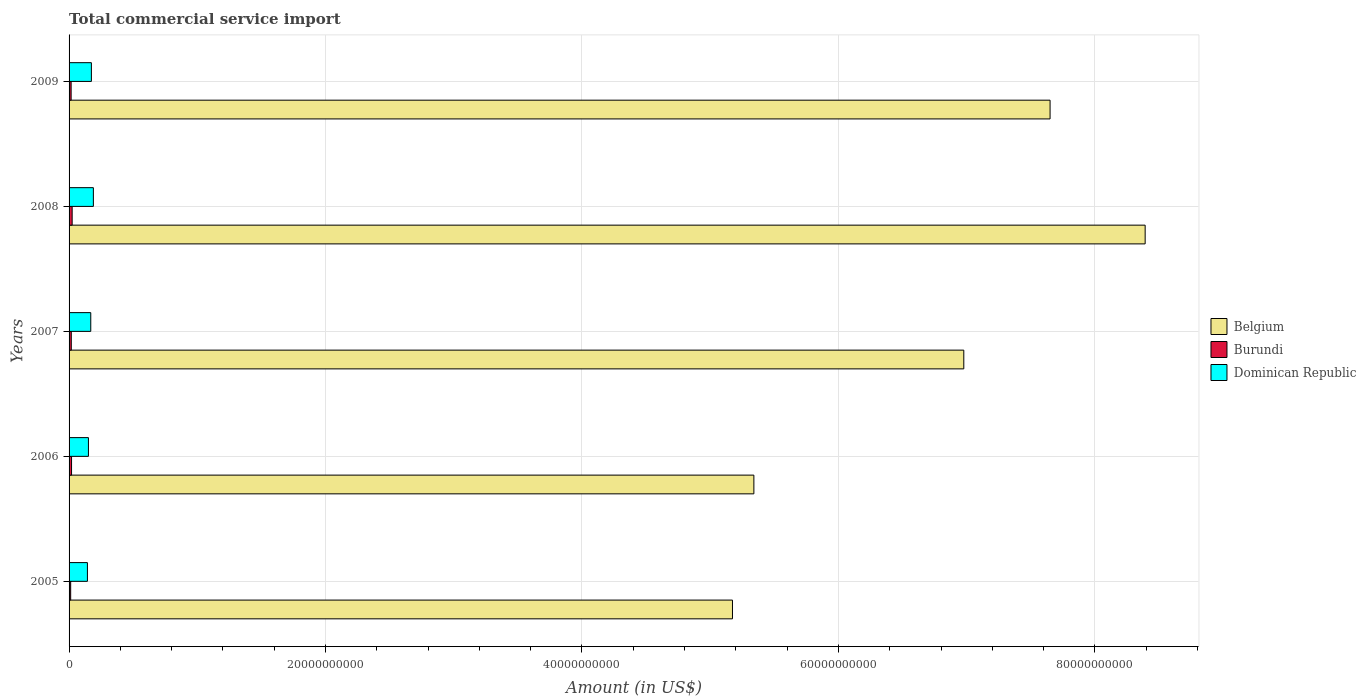How many different coloured bars are there?
Keep it short and to the point. 3. How many groups of bars are there?
Provide a succinct answer. 5. How many bars are there on the 5th tick from the top?
Your answer should be compact. 3. What is the label of the 3rd group of bars from the top?
Your answer should be very brief. 2007. In how many cases, is the number of bars for a given year not equal to the number of legend labels?
Make the answer very short. 0. What is the total commercial service import in Dominican Republic in 2006?
Ensure brevity in your answer.  1.51e+09. Across all years, what is the maximum total commercial service import in Dominican Republic?
Your answer should be very brief. 1.89e+09. Across all years, what is the minimum total commercial service import in Dominican Republic?
Offer a very short reply. 1.43e+09. In which year was the total commercial service import in Dominican Republic maximum?
Offer a terse response. 2008. In which year was the total commercial service import in Dominican Republic minimum?
Keep it short and to the point. 2005. What is the total total commercial service import in Burundi in the graph?
Offer a terse response. 8.92e+08. What is the difference between the total commercial service import in Belgium in 2006 and that in 2008?
Provide a short and direct response. -3.05e+1. What is the difference between the total commercial service import in Dominican Republic in 2005 and the total commercial service import in Burundi in 2009?
Offer a terse response. 1.27e+09. What is the average total commercial service import in Belgium per year?
Provide a succinct answer. 6.71e+1. In the year 2009, what is the difference between the total commercial service import in Dominican Republic and total commercial service import in Burundi?
Make the answer very short. 1.58e+09. In how many years, is the total commercial service import in Dominican Republic greater than 24000000000 US$?
Provide a succinct answer. 0. What is the ratio of the total commercial service import in Belgium in 2008 to that in 2009?
Keep it short and to the point. 1.1. What is the difference between the highest and the second highest total commercial service import in Dominican Republic?
Keep it short and to the point. 1.54e+08. What is the difference between the highest and the lowest total commercial service import in Belgium?
Ensure brevity in your answer.  3.22e+1. What does the 1st bar from the top in 2005 represents?
Keep it short and to the point. Dominican Republic. What does the 2nd bar from the bottom in 2009 represents?
Your answer should be compact. Burundi. How many bars are there?
Provide a succinct answer. 15. How many years are there in the graph?
Provide a short and direct response. 5. Does the graph contain grids?
Offer a very short reply. Yes. Where does the legend appear in the graph?
Provide a short and direct response. Center right. How are the legend labels stacked?
Offer a very short reply. Vertical. What is the title of the graph?
Provide a short and direct response. Total commercial service import. What is the Amount (in US$) of Belgium in 2005?
Your answer should be compact. 5.17e+1. What is the Amount (in US$) of Burundi in 2005?
Your response must be concise. 1.25e+08. What is the Amount (in US$) of Dominican Republic in 2005?
Your answer should be very brief. 1.43e+09. What is the Amount (in US$) of Belgium in 2006?
Offer a very short reply. 5.34e+1. What is the Amount (in US$) in Burundi in 2006?
Provide a short and direct response. 1.93e+08. What is the Amount (in US$) in Dominican Republic in 2006?
Give a very brief answer. 1.51e+09. What is the Amount (in US$) of Belgium in 2007?
Your answer should be very brief. 6.98e+1. What is the Amount (in US$) of Burundi in 2007?
Your response must be concise. 1.73e+08. What is the Amount (in US$) in Dominican Republic in 2007?
Make the answer very short. 1.69e+09. What is the Amount (in US$) of Belgium in 2008?
Keep it short and to the point. 8.39e+1. What is the Amount (in US$) of Burundi in 2008?
Provide a succinct answer. 2.41e+08. What is the Amount (in US$) in Dominican Republic in 2008?
Provide a short and direct response. 1.89e+09. What is the Amount (in US$) in Belgium in 2009?
Your answer should be compact. 7.65e+1. What is the Amount (in US$) in Burundi in 2009?
Make the answer very short. 1.60e+08. What is the Amount (in US$) of Dominican Republic in 2009?
Ensure brevity in your answer.  1.74e+09. Across all years, what is the maximum Amount (in US$) in Belgium?
Offer a terse response. 8.39e+1. Across all years, what is the maximum Amount (in US$) in Burundi?
Ensure brevity in your answer.  2.41e+08. Across all years, what is the maximum Amount (in US$) of Dominican Republic?
Ensure brevity in your answer.  1.89e+09. Across all years, what is the minimum Amount (in US$) of Belgium?
Provide a succinct answer. 5.17e+1. Across all years, what is the minimum Amount (in US$) of Burundi?
Provide a short and direct response. 1.25e+08. Across all years, what is the minimum Amount (in US$) in Dominican Republic?
Your answer should be compact. 1.43e+09. What is the total Amount (in US$) of Belgium in the graph?
Provide a short and direct response. 3.35e+11. What is the total Amount (in US$) in Burundi in the graph?
Offer a terse response. 8.92e+08. What is the total Amount (in US$) in Dominican Republic in the graph?
Offer a very short reply. 8.27e+09. What is the difference between the Amount (in US$) in Belgium in 2005 and that in 2006?
Your answer should be compact. -1.67e+09. What is the difference between the Amount (in US$) in Burundi in 2005 and that in 2006?
Keep it short and to the point. -6.88e+07. What is the difference between the Amount (in US$) of Dominican Republic in 2005 and that in 2006?
Offer a terse response. -7.95e+07. What is the difference between the Amount (in US$) in Belgium in 2005 and that in 2007?
Your answer should be compact. -1.80e+1. What is the difference between the Amount (in US$) of Burundi in 2005 and that in 2007?
Your response must be concise. -4.82e+07. What is the difference between the Amount (in US$) of Dominican Republic in 2005 and that in 2007?
Your answer should be very brief. -2.61e+08. What is the difference between the Amount (in US$) in Belgium in 2005 and that in 2008?
Ensure brevity in your answer.  -3.22e+1. What is the difference between the Amount (in US$) of Burundi in 2005 and that in 2008?
Ensure brevity in your answer.  -1.16e+08. What is the difference between the Amount (in US$) of Dominican Republic in 2005 and that in 2008?
Give a very brief answer. -4.64e+08. What is the difference between the Amount (in US$) of Belgium in 2005 and that in 2009?
Provide a short and direct response. -2.48e+1. What is the difference between the Amount (in US$) in Burundi in 2005 and that in 2009?
Offer a terse response. -3.54e+07. What is the difference between the Amount (in US$) in Dominican Republic in 2005 and that in 2009?
Your answer should be compact. -3.10e+08. What is the difference between the Amount (in US$) in Belgium in 2006 and that in 2007?
Give a very brief answer. -1.64e+1. What is the difference between the Amount (in US$) in Burundi in 2006 and that in 2007?
Offer a terse response. 2.06e+07. What is the difference between the Amount (in US$) in Dominican Republic in 2006 and that in 2007?
Your answer should be compact. -1.81e+08. What is the difference between the Amount (in US$) of Belgium in 2006 and that in 2008?
Offer a terse response. -3.05e+1. What is the difference between the Amount (in US$) of Burundi in 2006 and that in 2008?
Keep it short and to the point. -4.70e+07. What is the difference between the Amount (in US$) of Dominican Republic in 2006 and that in 2008?
Your response must be concise. -3.84e+08. What is the difference between the Amount (in US$) in Belgium in 2006 and that in 2009?
Provide a succinct answer. -2.31e+1. What is the difference between the Amount (in US$) in Burundi in 2006 and that in 2009?
Give a very brief answer. 3.34e+07. What is the difference between the Amount (in US$) of Dominican Republic in 2006 and that in 2009?
Your response must be concise. -2.31e+08. What is the difference between the Amount (in US$) in Belgium in 2007 and that in 2008?
Offer a very short reply. -1.41e+1. What is the difference between the Amount (in US$) of Burundi in 2007 and that in 2008?
Provide a succinct answer. -6.77e+07. What is the difference between the Amount (in US$) of Dominican Republic in 2007 and that in 2008?
Offer a terse response. -2.03e+08. What is the difference between the Amount (in US$) of Belgium in 2007 and that in 2009?
Ensure brevity in your answer.  -6.73e+09. What is the difference between the Amount (in US$) in Burundi in 2007 and that in 2009?
Your response must be concise. 1.27e+07. What is the difference between the Amount (in US$) of Dominican Republic in 2007 and that in 2009?
Your answer should be compact. -4.96e+07. What is the difference between the Amount (in US$) of Belgium in 2008 and that in 2009?
Offer a terse response. 7.42e+09. What is the difference between the Amount (in US$) of Burundi in 2008 and that in 2009?
Offer a very short reply. 8.04e+07. What is the difference between the Amount (in US$) of Dominican Republic in 2008 and that in 2009?
Give a very brief answer. 1.54e+08. What is the difference between the Amount (in US$) of Belgium in 2005 and the Amount (in US$) of Burundi in 2006?
Provide a short and direct response. 5.15e+1. What is the difference between the Amount (in US$) of Belgium in 2005 and the Amount (in US$) of Dominican Republic in 2006?
Your answer should be very brief. 5.02e+1. What is the difference between the Amount (in US$) in Burundi in 2005 and the Amount (in US$) in Dominican Republic in 2006?
Offer a terse response. -1.39e+09. What is the difference between the Amount (in US$) of Belgium in 2005 and the Amount (in US$) of Burundi in 2007?
Your answer should be compact. 5.16e+1. What is the difference between the Amount (in US$) of Belgium in 2005 and the Amount (in US$) of Dominican Republic in 2007?
Give a very brief answer. 5.00e+1. What is the difference between the Amount (in US$) in Burundi in 2005 and the Amount (in US$) in Dominican Republic in 2007?
Your answer should be very brief. -1.57e+09. What is the difference between the Amount (in US$) in Belgium in 2005 and the Amount (in US$) in Burundi in 2008?
Offer a terse response. 5.15e+1. What is the difference between the Amount (in US$) in Belgium in 2005 and the Amount (in US$) in Dominican Republic in 2008?
Make the answer very short. 4.98e+1. What is the difference between the Amount (in US$) in Burundi in 2005 and the Amount (in US$) in Dominican Republic in 2008?
Offer a terse response. -1.77e+09. What is the difference between the Amount (in US$) of Belgium in 2005 and the Amount (in US$) of Burundi in 2009?
Your answer should be very brief. 5.16e+1. What is the difference between the Amount (in US$) of Belgium in 2005 and the Amount (in US$) of Dominican Republic in 2009?
Offer a very short reply. 5.00e+1. What is the difference between the Amount (in US$) of Burundi in 2005 and the Amount (in US$) of Dominican Republic in 2009?
Offer a very short reply. -1.62e+09. What is the difference between the Amount (in US$) in Belgium in 2006 and the Amount (in US$) in Burundi in 2007?
Ensure brevity in your answer.  5.32e+1. What is the difference between the Amount (in US$) of Belgium in 2006 and the Amount (in US$) of Dominican Republic in 2007?
Provide a succinct answer. 5.17e+1. What is the difference between the Amount (in US$) of Burundi in 2006 and the Amount (in US$) of Dominican Republic in 2007?
Offer a very short reply. -1.50e+09. What is the difference between the Amount (in US$) of Belgium in 2006 and the Amount (in US$) of Burundi in 2008?
Your answer should be very brief. 5.32e+1. What is the difference between the Amount (in US$) in Belgium in 2006 and the Amount (in US$) in Dominican Republic in 2008?
Provide a succinct answer. 5.15e+1. What is the difference between the Amount (in US$) of Burundi in 2006 and the Amount (in US$) of Dominican Republic in 2008?
Provide a short and direct response. -1.70e+09. What is the difference between the Amount (in US$) of Belgium in 2006 and the Amount (in US$) of Burundi in 2009?
Your response must be concise. 5.32e+1. What is the difference between the Amount (in US$) of Belgium in 2006 and the Amount (in US$) of Dominican Republic in 2009?
Your answer should be compact. 5.17e+1. What is the difference between the Amount (in US$) in Burundi in 2006 and the Amount (in US$) in Dominican Republic in 2009?
Offer a terse response. -1.55e+09. What is the difference between the Amount (in US$) in Belgium in 2007 and the Amount (in US$) in Burundi in 2008?
Offer a terse response. 6.95e+1. What is the difference between the Amount (in US$) in Belgium in 2007 and the Amount (in US$) in Dominican Republic in 2008?
Make the answer very short. 6.79e+1. What is the difference between the Amount (in US$) of Burundi in 2007 and the Amount (in US$) of Dominican Republic in 2008?
Give a very brief answer. -1.72e+09. What is the difference between the Amount (in US$) of Belgium in 2007 and the Amount (in US$) of Burundi in 2009?
Keep it short and to the point. 6.96e+1. What is the difference between the Amount (in US$) of Belgium in 2007 and the Amount (in US$) of Dominican Republic in 2009?
Your response must be concise. 6.80e+1. What is the difference between the Amount (in US$) in Burundi in 2007 and the Amount (in US$) in Dominican Republic in 2009?
Your answer should be compact. -1.57e+09. What is the difference between the Amount (in US$) in Belgium in 2008 and the Amount (in US$) in Burundi in 2009?
Give a very brief answer. 8.38e+1. What is the difference between the Amount (in US$) of Belgium in 2008 and the Amount (in US$) of Dominican Republic in 2009?
Provide a succinct answer. 8.22e+1. What is the difference between the Amount (in US$) of Burundi in 2008 and the Amount (in US$) of Dominican Republic in 2009?
Offer a very short reply. -1.50e+09. What is the average Amount (in US$) of Belgium per year?
Offer a very short reply. 6.71e+1. What is the average Amount (in US$) of Burundi per year?
Keep it short and to the point. 1.78e+08. What is the average Amount (in US$) of Dominican Republic per year?
Make the answer very short. 1.65e+09. In the year 2005, what is the difference between the Amount (in US$) of Belgium and Amount (in US$) of Burundi?
Your response must be concise. 5.16e+1. In the year 2005, what is the difference between the Amount (in US$) in Belgium and Amount (in US$) in Dominican Republic?
Provide a succinct answer. 5.03e+1. In the year 2005, what is the difference between the Amount (in US$) of Burundi and Amount (in US$) of Dominican Republic?
Offer a very short reply. -1.31e+09. In the year 2006, what is the difference between the Amount (in US$) of Belgium and Amount (in US$) of Burundi?
Provide a short and direct response. 5.32e+1. In the year 2006, what is the difference between the Amount (in US$) in Belgium and Amount (in US$) in Dominican Republic?
Your response must be concise. 5.19e+1. In the year 2006, what is the difference between the Amount (in US$) in Burundi and Amount (in US$) in Dominican Republic?
Provide a succinct answer. -1.32e+09. In the year 2007, what is the difference between the Amount (in US$) of Belgium and Amount (in US$) of Burundi?
Give a very brief answer. 6.96e+1. In the year 2007, what is the difference between the Amount (in US$) of Belgium and Amount (in US$) of Dominican Republic?
Give a very brief answer. 6.81e+1. In the year 2007, what is the difference between the Amount (in US$) of Burundi and Amount (in US$) of Dominican Republic?
Provide a short and direct response. -1.52e+09. In the year 2008, what is the difference between the Amount (in US$) of Belgium and Amount (in US$) of Burundi?
Keep it short and to the point. 8.37e+1. In the year 2008, what is the difference between the Amount (in US$) of Belgium and Amount (in US$) of Dominican Republic?
Give a very brief answer. 8.20e+1. In the year 2008, what is the difference between the Amount (in US$) of Burundi and Amount (in US$) of Dominican Republic?
Your answer should be very brief. -1.65e+09. In the year 2009, what is the difference between the Amount (in US$) of Belgium and Amount (in US$) of Burundi?
Offer a terse response. 7.63e+1. In the year 2009, what is the difference between the Amount (in US$) in Belgium and Amount (in US$) in Dominican Republic?
Your answer should be very brief. 7.48e+1. In the year 2009, what is the difference between the Amount (in US$) in Burundi and Amount (in US$) in Dominican Republic?
Provide a succinct answer. -1.58e+09. What is the ratio of the Amount (in US$) in Belgium in 2005 to that in 2006?
Your answer should be very brief. 0.97. What is the ratio of the Amount (in US$) of Burundi in 2005 to that in 2006?
Ensure brevity in your answer.  0.64. What is the ratio of the Amount (in US$) of Dominican Republic in 2005 to that in 2006?
Your answer should be very brief. 0.95. What is the ratio of the Amount (in US$) of Belgium in 2005 to that in 2007?
Give a very brief answer. 0.74. What is the ratio of the Amount (in US$) of Burundi in 2005 to that in 2007?
Provide a short and direct response. 0.72. What is the ratio of the Amount (in US$) in Dominican Republic in 2005 to that in 2007?
Give a very brief answer. 0.85. What is the ratio of the Amount (in US$) in Belgium in 2005 to that in 2008?
Your response must be concise. 0.62. What is the ratio of the Amount (in US$) in Burundi in 2005 to that in 2008?
Offer a terse response. 0.52. What is the ratio of the Amount (in US$) of Dominican Republic in 2005 to that in 2008?
Provide a succinct answer. 0.76. What is the ratio of the Amount (in US$) in Belgium in 2005 to that in 2009?
Give a very brief answer. 0.68. What is the ratio of the Amount (in US$) of Burundi in 2005 to that in 2009?
Make the answer very short. 0.78. What is the ratio of the Amount (in US$) in Dominican Republic in 2005 to that in 2009?
Provide a short and direct response. 0.82. What is the ratio of the Amount (in US$) of Belgium in 2006 to that in 2007?
Provide a short and direct response. 0.77. What is the ratio of the Amount (in US$) of Burundi in 2006 to that in 2007?
Keep it short and to the point. 1.12. What is the ratio of the Amount (in US$) in Dominican Republic in 2006 to that in 2007?
Keep it short and to the point. 0.89. What is the ratio of the Amount (in US$) in Belgium in 2006 to that in 2008?
Provide a short and direct response. 0.64. What is the ratio of the Amount (in US$) of Burundi in 2006 to that in 2008?
Your response must be concise. 0.8. What is the ratio of the Amount (in US$) of Dominican Republic in 2006 to that in 2008?
Provide a succinct answer. 0.8. What is the ratio of the Amount (in US$) of Belgium in 2006 to that in 2009?
Provide a succinct answer. 0.7. What is the ratio of the Amount (in US$) in Burundi in 2006 to that in 2009?
Your response must be concise. 1.21. What is the ratio of the Amount (in US$) of Dominican Republic in 2006 to that in 2009?
Your answer should be very brief. 0.87. What is the ratio of the Amount (in US$) of Belgium in 2007 to that in 2008?
Your response must be concise. 0.83. What is the ratio of the Amount (in US$) in Burundi in 2007 to that in 2008?
Make the answer very short. 0.72. What is the ratio of the Amount (in US$) of Dominican Republic in 2007 to that in 2008?
Make the answer very short. 0.89. What is the ratio of the Amount (in US$) of Belgium in 2007 to that in 2009?
Give a very brief answer. 0.91. What is the ratio of the Amount (in US$) in Burundi in 2007 to that in 2009?
Offer a very short reply. 1.08. What is the ratio of the Amount (in US$) in Dominican Republic in 2007 to that in 2009?
Your response must be concise. 0.97. What is the ratio of the Amount (in US$) of Belgium in 2008 to that in 2009?
Make the answer very short. 1.1. What is the ratio of the Amount (in US$) in Burundi in 2008 to that in 2009?
Your response must be concise. 1.5. What is the ratio of the Amount (in US$) of Dominican Republic in 2008 to that in 2009?
Provide a succinct answer. 1.09. What is the difference between the highest and the second highest Amount (in US$) in Belgium?
Provide a succinct answer. 7.42e+09. What is the difference between the highest and the second highest Amount (in US$) in Burundi?
Your answer should be very brief. 4.70e+07. What is the difference between the highest and the second highest Amount (in US$) in Dominican Republic?
Your response must be concise. 1.54e+08. What is the difference between the highest and the lowest Amount (in US$) of Belgium?
Your response must be concise. 3.22e+1. What is the difference between the highest and the lowest Amount (in US$) in Burundi?
Make the answer very short. 1.16e+08. What is the difference between the highest and the lowest Amount (in US$) in Dominican Republic?
Give a very brief answer. 4.64e+08. 